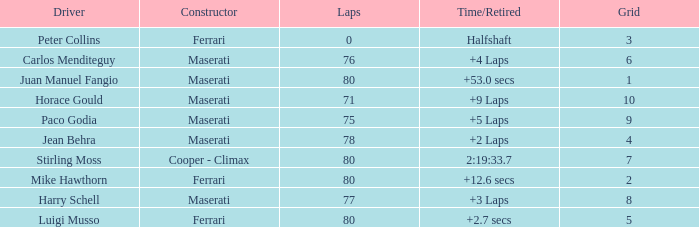What's the average Grid for a Maserati with less than 80 laps, and a Time/Retired of +2 laps? 4.0. 